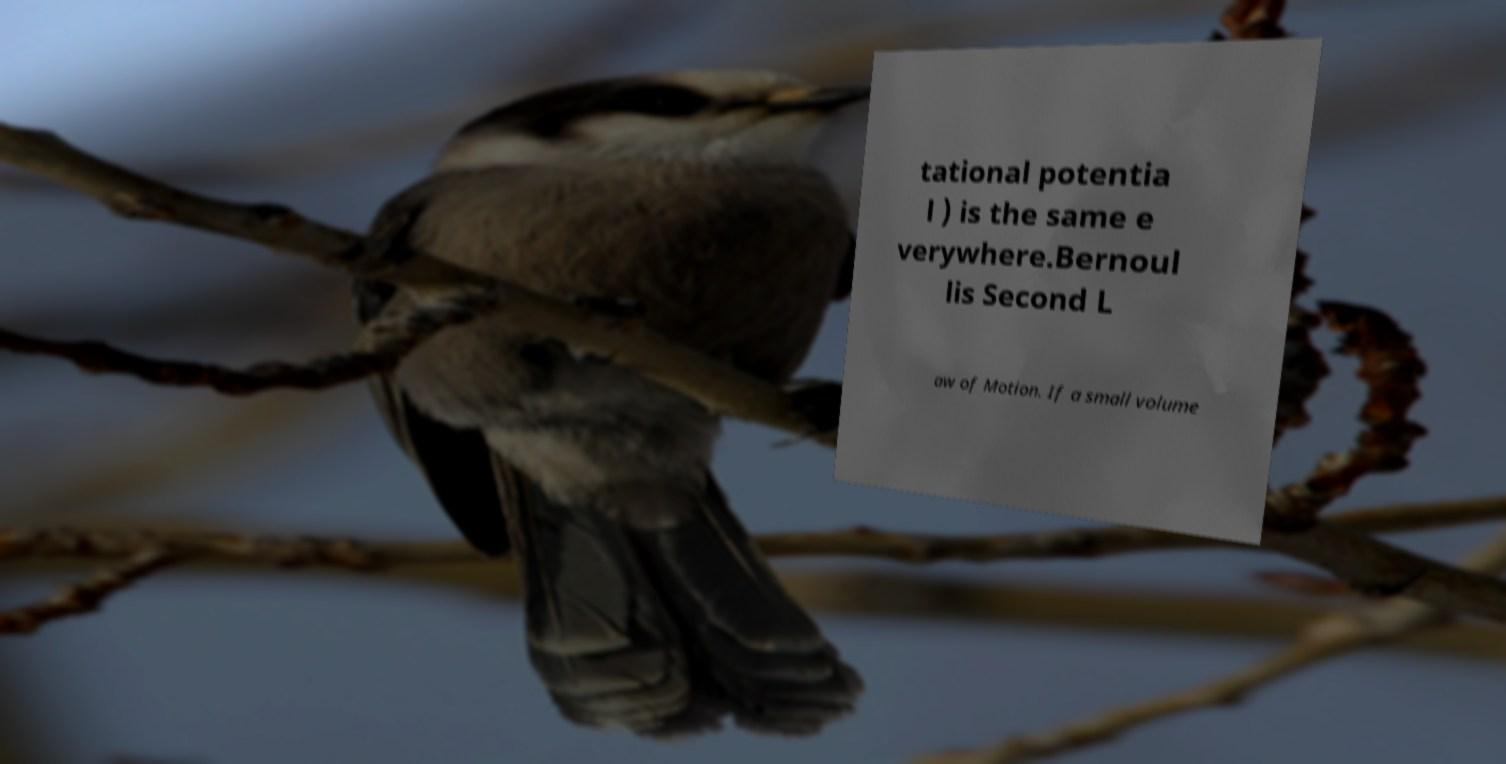What messages or text are displayed in this image? I need them in a readable, typed format. tational potentia l ) is the same e verywhere.Bernoul lis Second L aw of Motion. If a small volume 